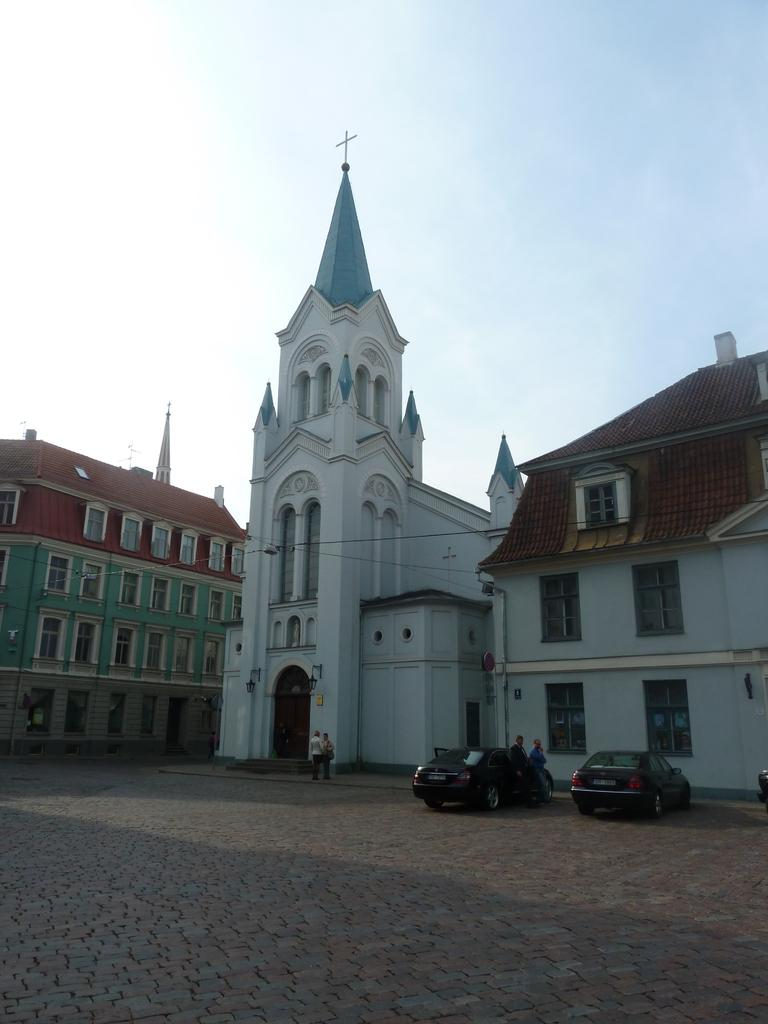What type of structures can be seen in the image? There are buildings in the image. What are some of the vehicles visible in the image? There are cars parked in the image. What are the people in the image doing? There are people walking and standing in the image. What is the condition of the sky in the image? The sky is cloudy in the image. What is the title of the book being read by the person in the image? There is no book or person reading in the image. How does the image compare to a similar scene in a different city? The image cannot be compared to a similar scene in a different city, as we do not have any information about other cities or scenes. 